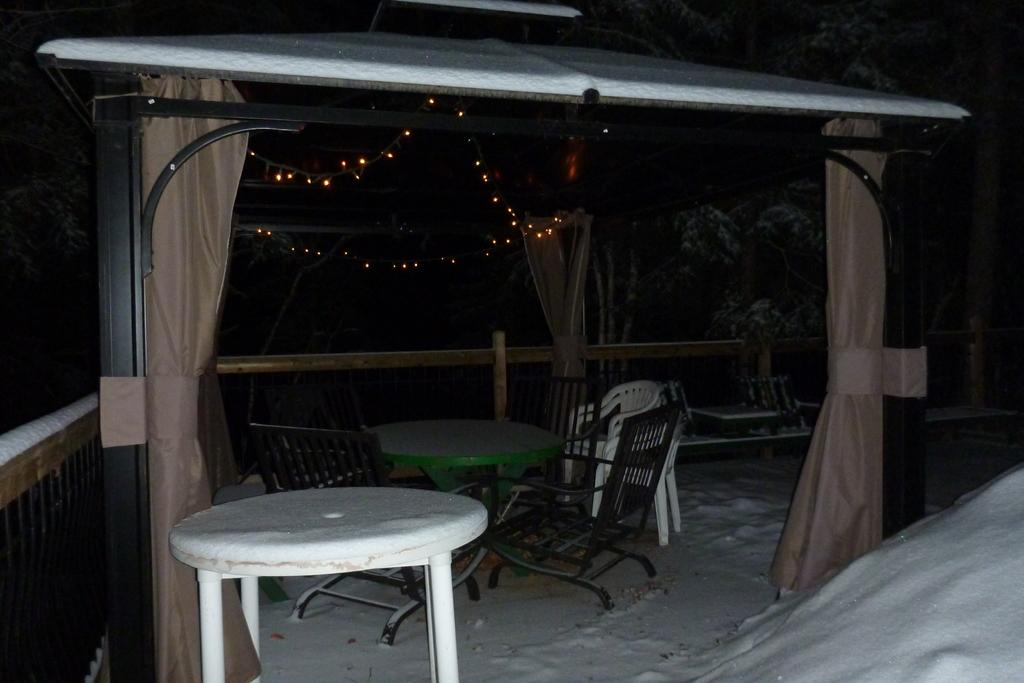What type of furniture is present in the image? There are tables, chairs, and benches in the image. What type of window treatment can be seen in the image? There are curtains in the image. What type of architectural elements are present in the image? There are poles in the image. What type of lighting is visible in the background of the image? There are string lights in the background of the image. What can be seen in the distance in the image? There are trees in the background of the image. What type of pancake is being served in the image? There is no pancake present in the image. What subject is being taught in the class depicted in the image? There is no class depicted in the image. 